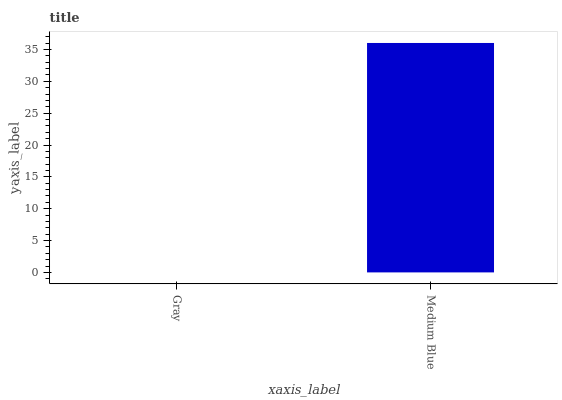Is Gray the minimum?
Answer yes or no. Yes. Is Medium Blue the maximum?
Answer yes or no. Yes. Is Medium Blue the minimum?
Answer yes or no. No. Is Medium Blue greater than Gray?
Answer yes or no. Yes. Is Gray less than Medium Blue?
Answer yes or no. Yes. Is Gray greater than Medium Blue?
Answer yes or no. No. Is Medium Blue less than Gray?
Answer yes or no. No. Is Medium Blue the high median?
Answer yes or no. Yes. Is Gray the low median?
Answer yes or no. Yes. Is Gray the high median?
Answer yes or no. No. Is Medium Blue the low median?
Answer yes or no. No. 